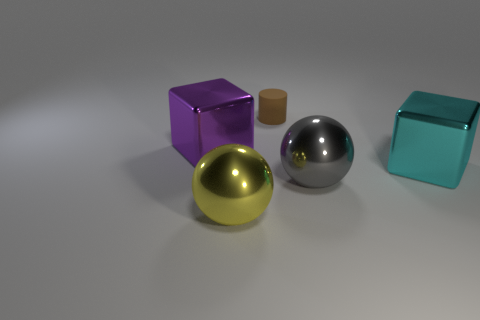Are the big cube behind the large cyan block and the big cyan thing made of the same material?
Your answer should be compact. Yes. Is there any other thing that has the same material as the big yellow thing?
Your answer should be very brief. Yes. How many large cubes are behind the cube that is in front of the shiny cube that is to the left of the tiny cylinder?
Offer a very short reply. 1. Is the shape of the large shiny thing that is to the right of the big gray object the same as  the brown matte thing?
Provide a short and direct response. No. What number of objects are yellow metallic balls or spheres left of the rubber cylinder?
Make the answer very short. 1. Are there more yellow shiny spheres that are behind the large purple metal cube than big yellow metal blocks?
Keep it short and to the point. No. Is the number of brown matte cylinders that are in front of the rubber object the same as the number of large cyan cubes behind the big purple block?
Provide a short and direct response. Yes. There is a big object that is behind the cyan shiny object; is there a rubber thing that is left of it?
Provide a short and direct response. No. What is the shape of the big yellow thing?
Provide a succinct answer. Sphere. There is a shiny block in front of the big shiny cube to the left of the yellow metallic thing; how big is it?
Ensure brevity in your answer.  Large. 